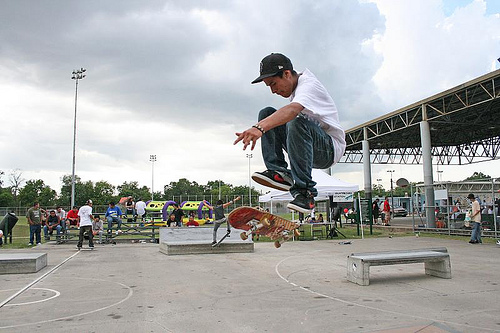<image>
Can you confirm if the boy is on the ground? No. The boy is not positioned on the ground. They may be near each other, but the boy is not supported by or resting on top of the ground. Is there a skating board under the man? Yes. The skating board is positioned underneath the man, with the man above it in the vertical space. 